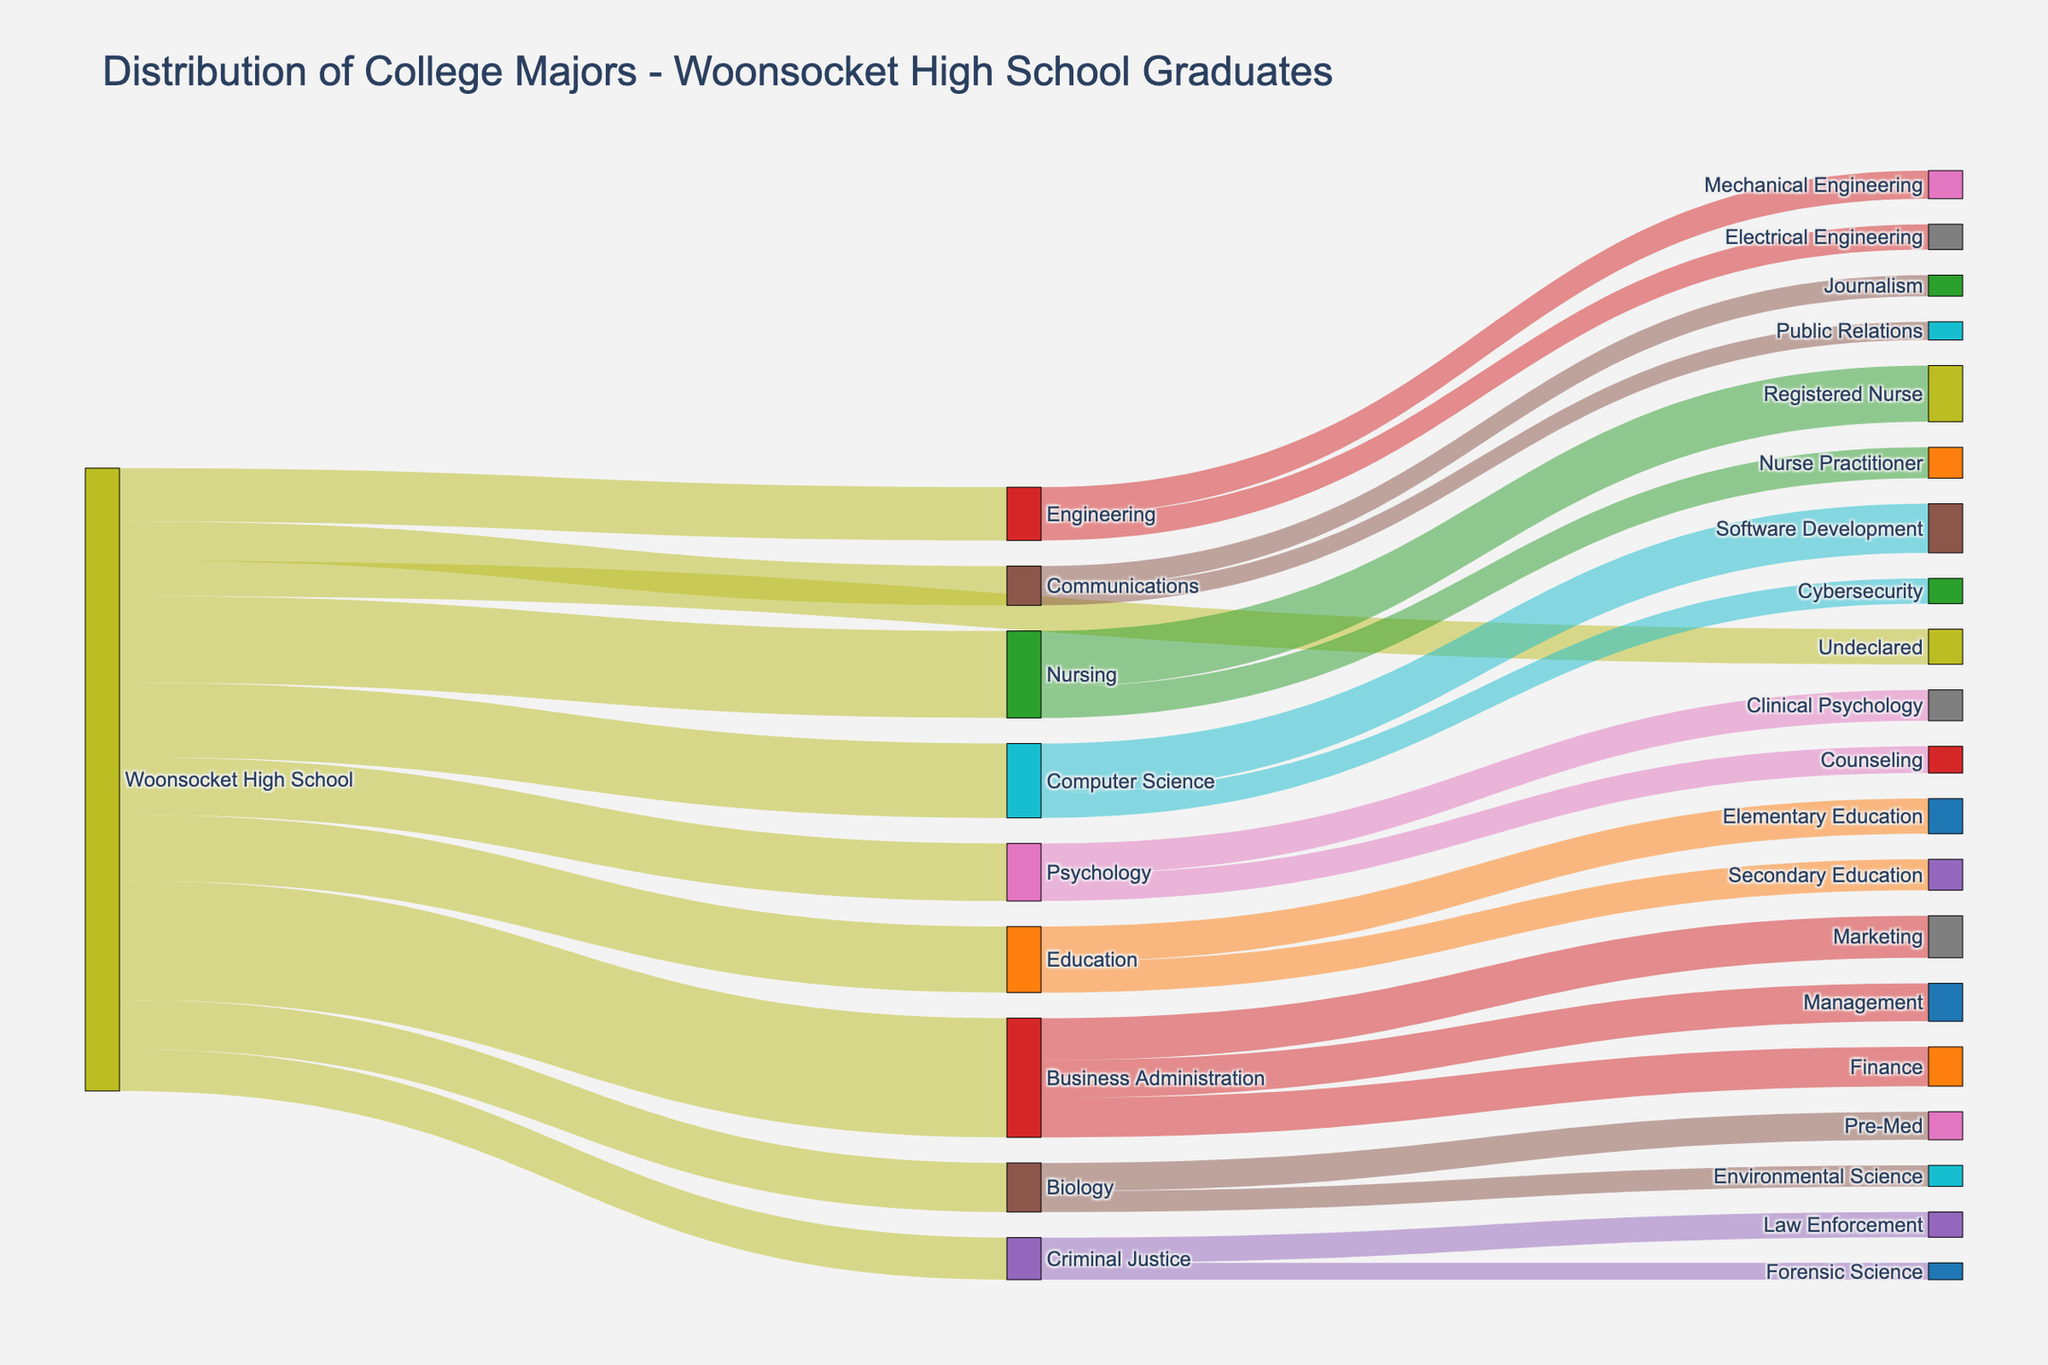Which major has the highest number of graduates from Woonsocket High School? By looking at the nodes connected to "Woonsocket High School" and observing the link values, we see that "Business Administration" has the highest value of 85 graduates
Answer: Business Administration How many graduates chose undecided as their initial major? Identifying the node "Undeclared" connected to "Woonsocket High School," we see that the corresponding link value is 25.
Answer: 25 What are the top three majors chosen by graduates from Woonsocket High School? Reviewing the nodes linked to "Woonsocket High School," the values for each major are 85 (Business Administration), 62 (Nursing), and 53 (Computer Science), making them the top three majors chosen.
Answer: Business Administration, Nursing, Computer Science How many graduates moved from Nursing to either Registered Nurse or Nurse Practitioner? Checking the links originating from Nursing, the values are 40 for Registered Nurse and 22 for Nurse Practitioner, which sum up to 62.
Answer: 62 Which career path has the highest number of graduates from Business Administration? Reviewing the target nodes linked to "Business Administration," the highest link value is for "Marketing" with 30 graduates.
Answer: Marketing What is the ratio of graduates in Engineering to those in Education from Woonsocket High School? Viewing the nodes "Engineering" (38 graduates) and "Education" (47 graduates) emerging from "Woonsocket High School," the ratio is 38 to 47.
Answer: 38:47 Which majors have fewer than 30 graduates from Woonsocket High School? Observing the initial nodes connected to Woonsocket High School, Criminal Justice (30), Communications (28), and Undeclared (25) have fewer than 30 graduates.
Answer: Communications, Undeclared What is the total number of graduates pursuing specialized fields from Computer Science? Checking the links originating from "Computer Science," the sum of graduates moving into "Software Development" (35) and "Cybersecurity" (18) is 53.
Answer: 53 Which major contributes the least number of graduates to careers in Finance, and what is that number? By examining the distribution from "Business Administration," the key value for Finance is 28 which is the tallest link value among the margin.
Answer: Finance, 28 